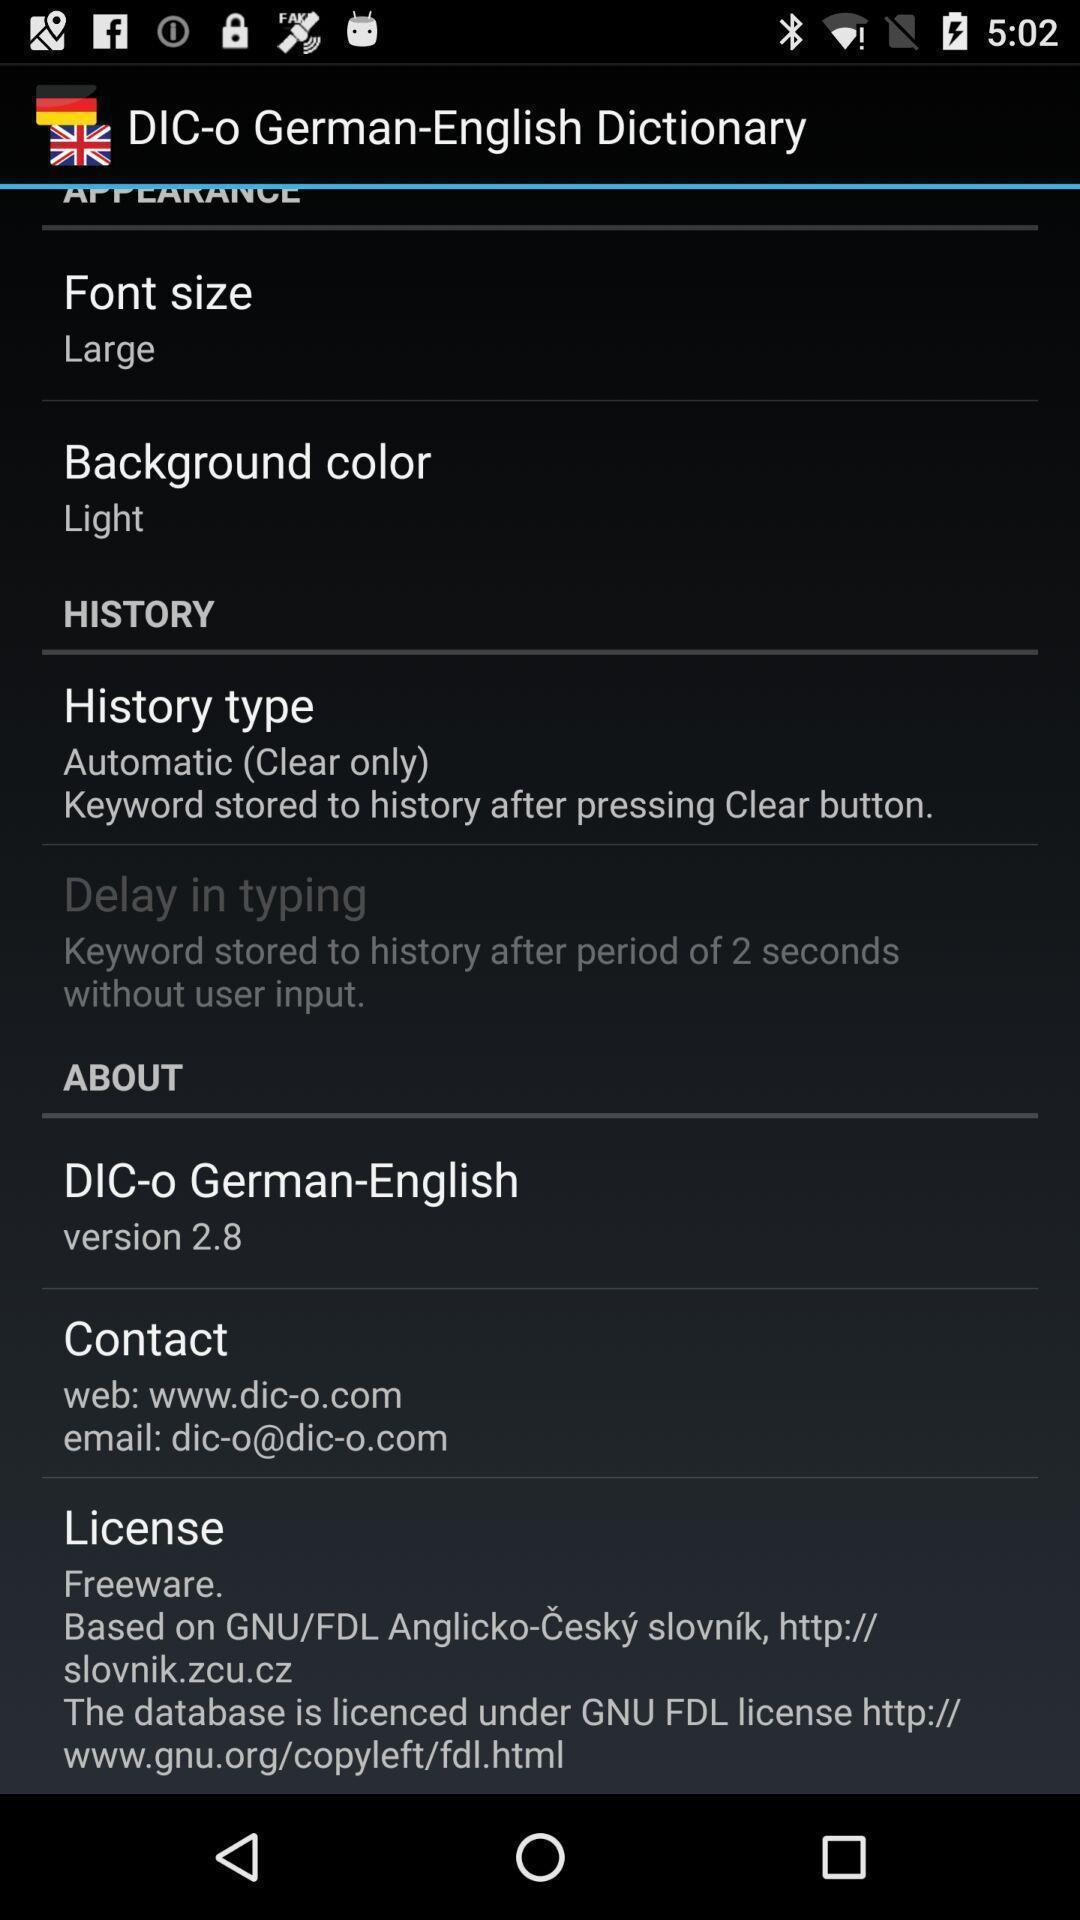Describe the content in this image. Screen of dictionary app showing details. 